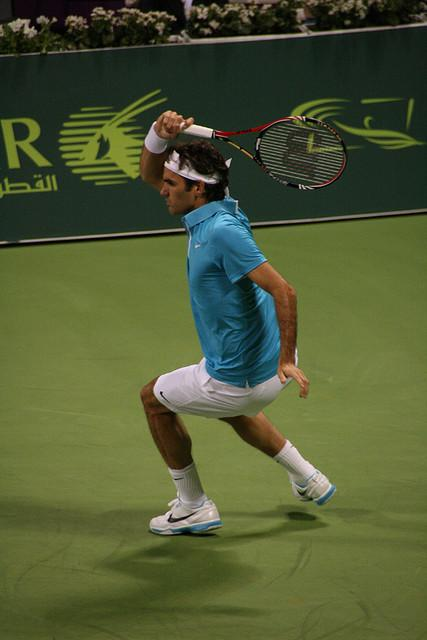What is the athletes last name? Please explain your reasoning. federer. A man with dark hair is playing tennis. 